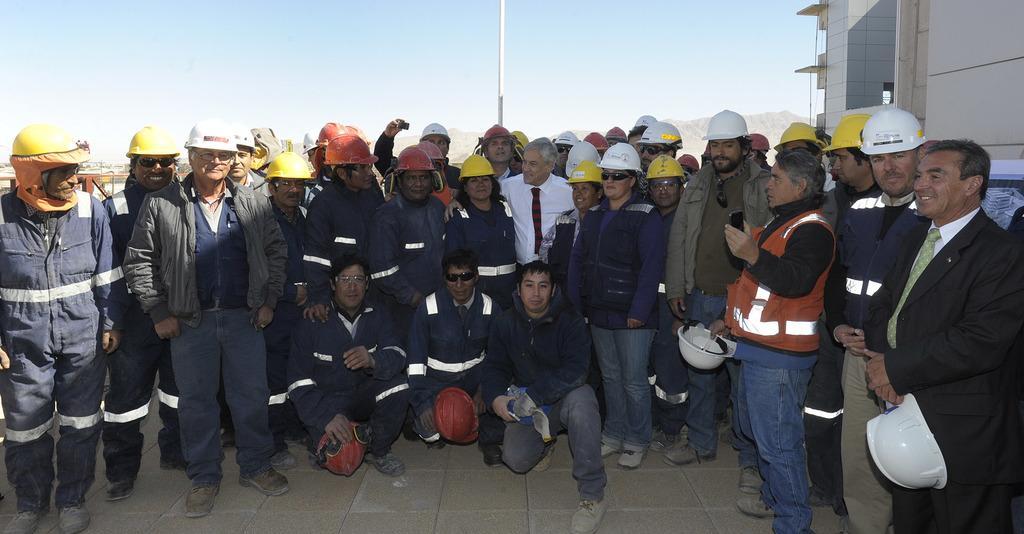How would you summarize this image in a sentence or two? In this image in the middle, there are group of people visible on the floor, in the middle there is a pole, at the top there is the sky, in the top right there may be the building. 